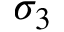<formula> <loc_0><loc_0><loc_500><loc_500>\sigma _ { 3 }</formula> 